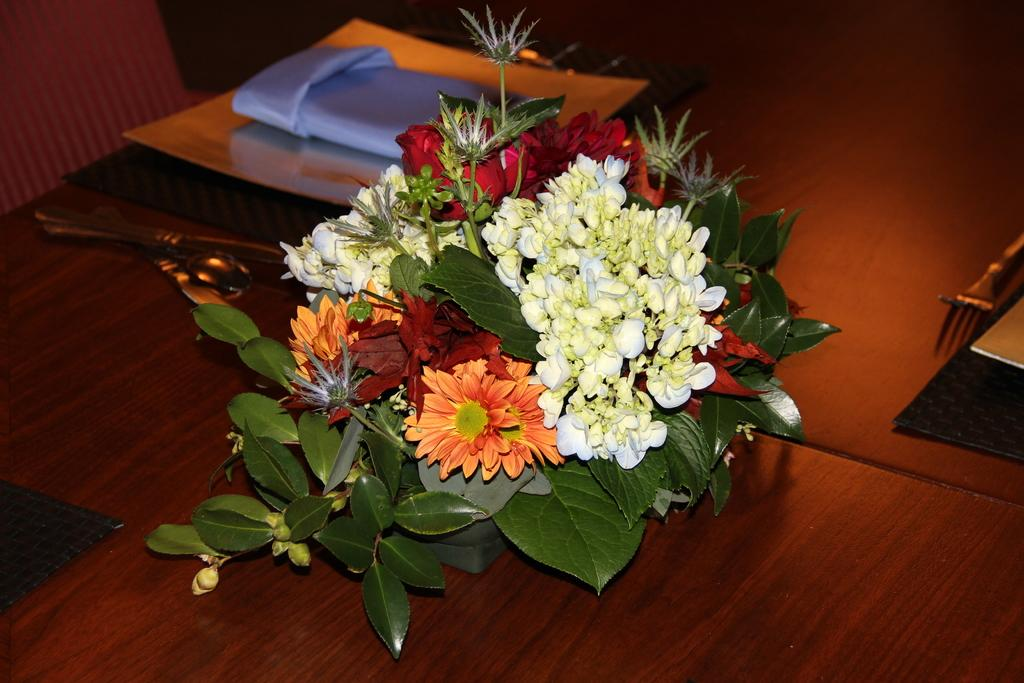What type of plants can be seen in the image? There are flowers and leaves in the image. What utensils are visible in the image? There are spoons and a fork in the image. What is covering the table in the image? There is a cloth on the table in the image. What type of error can be seen in the image? There is no error present in the image. How much money is visible in the image? There is no money present in the image. What religious symbols can be seen in the image? There are no religious symbols present in the image. 